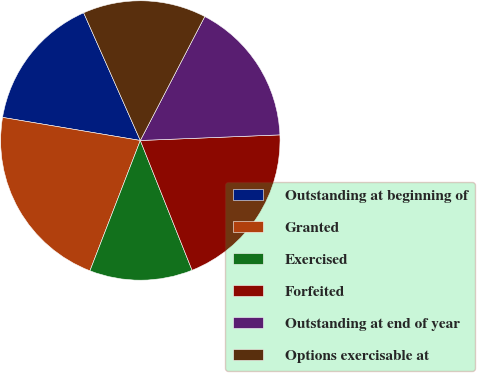<chart> <loc_0><loc_0><loc_500><loc_500><pie_chart><fcel>Outstanding at beginning of<fcel>Granted<fcel>Exercised<fcel>Forfeited<fcel>Outstanding at end of year<fcel>Options exercisable at<nl><fcel>15.71%<fcel>21.77%<fcel>11.91%<fcel>19.6%<fcel>16.73%<fcel>14.28%<nl></chart> 